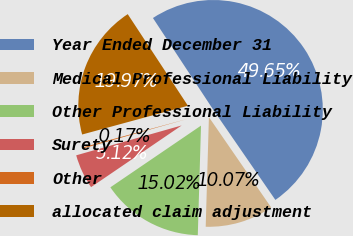Convert chart. <chart><loc_0><loc_0><loc_500><loc_500><pie_chart><fcel>Year Ended December 31<fcel>Medical Professional Liability<fcel>Other Professional Liability<fcel>Surety<fcel>Other<fcel>allocated claim adjustment<nl><fcel>49.65%<fcel>10.07%<fcel>15.02%<fcel>5.12%<fcel>0.17%<fcel>19.97%<nl></chart> 